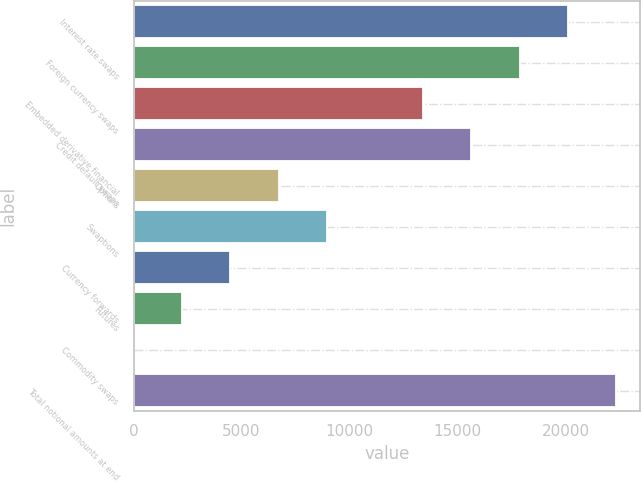Convert chart. <chart><loc_0><loc_0><loc_500><loc_500><bar_chart><fcel>Interest rate swaps<fcel>Foreign currency swaps<fcel>Embedded derivative financial<fcel>Credit default swaps<fcel>Options<fcel>Swaptions<fcel>Currency forwards<fcel>Futures<fcel>Commodity swaps<fcel>Total notional amounts at end<nl><fcel>20100.6<fcel>17869.4<fcel>13407.1<fcel>15638.3<fcel>6713.54<fcel>8944.72<fcel>4482.36<fcel>2251.18<fcel>20<fcel>22331.8<nl></chart> 